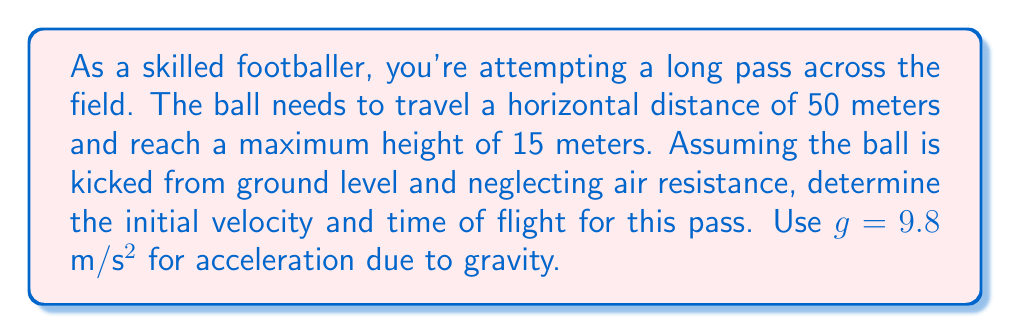What is the answer to this math problem? Let's approach this step-by-step using the equations of motion for projectile motion:

1) First, we'll use the equation for the maximum height of a projectile:
   $$y_{max} = \frac{(v_0 \sin \theta)^2}{2g}$$
   where $y_{max} = 15$ m, $g = 9.8$ m/s², and $\theta = 45°$ (for maximum range)

2) Substituting these values:
   $$15 = \frac{(v_0 \sin 45°)^2}{2(9.8)}$$

3) Simplify:
   $$15 = \frac{(v_0 \cdot 0.707)^2}{19.6}$$

4) Solve for $v_0$:
   $$v_0 = \sqrt{\frac{15 \cdot 19.6}{0.707^2}} \approx 24.49 \text{ m/s}$$

5) Now, for the horizontal distance:
   $$x = v_0 \cos \theta \cdot t$$
   where $x = 50$ m and $t$ is the time of flight

6) Substitute known values:
   $$50 = 24.49 \cos 45° \cdot t$$

7) Solve for $t$:
   $$t = \frac{50}{24.49 \cdot 0.707} \approx 2.89 \text{ seconds}$$

Thus, the initial velocity is approximately 24.49 m/s and the time of flight is about 2.89 seconds.
Answer: $v_0 \approx 24.49$ m/s, $t \approx 2.89$ s 